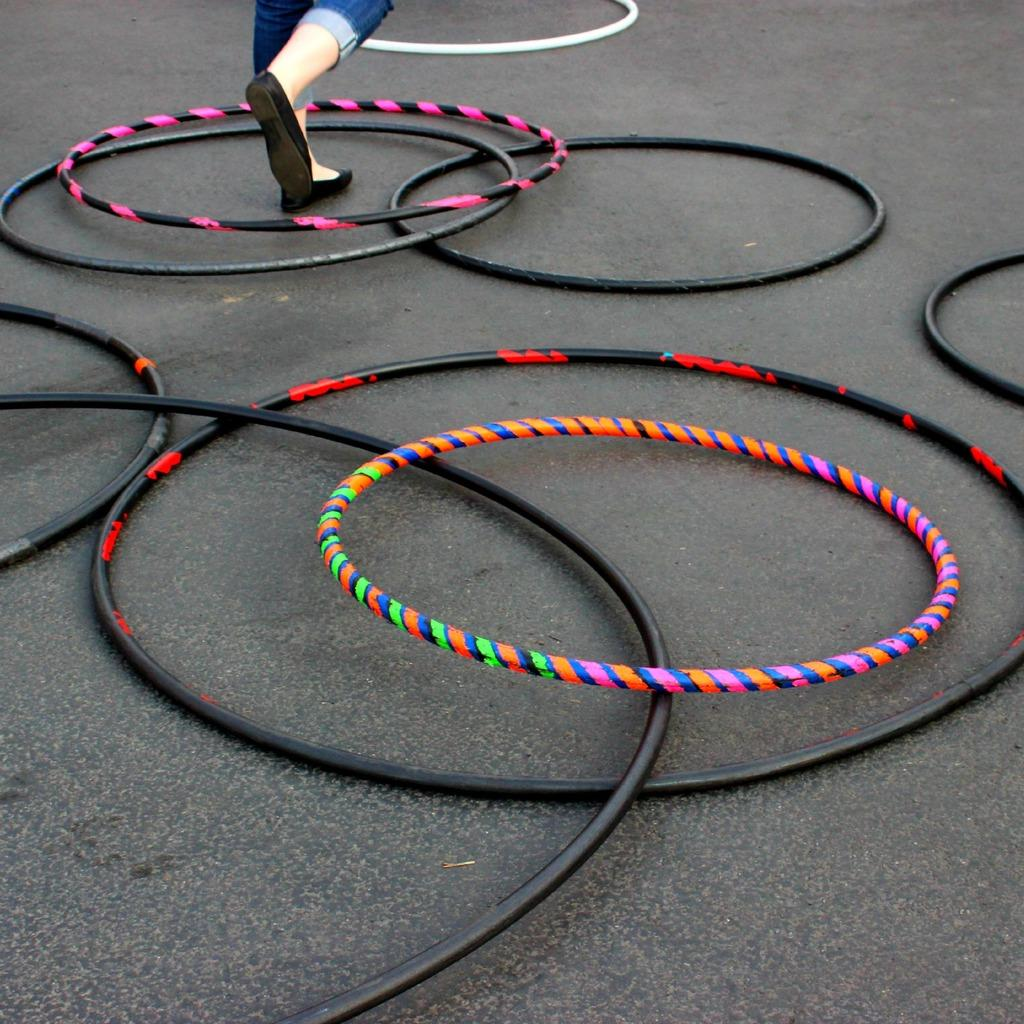What objects are on the road in the image? There are hula hoops on the road in the image. Can you describe any human presence in the image? Yes, there are legs of a person visible in the image. What type of suit is the person wearing in the alley in the image? There is no suit or alley present in the image; it only features hula hoops on the road and legs of a person. 